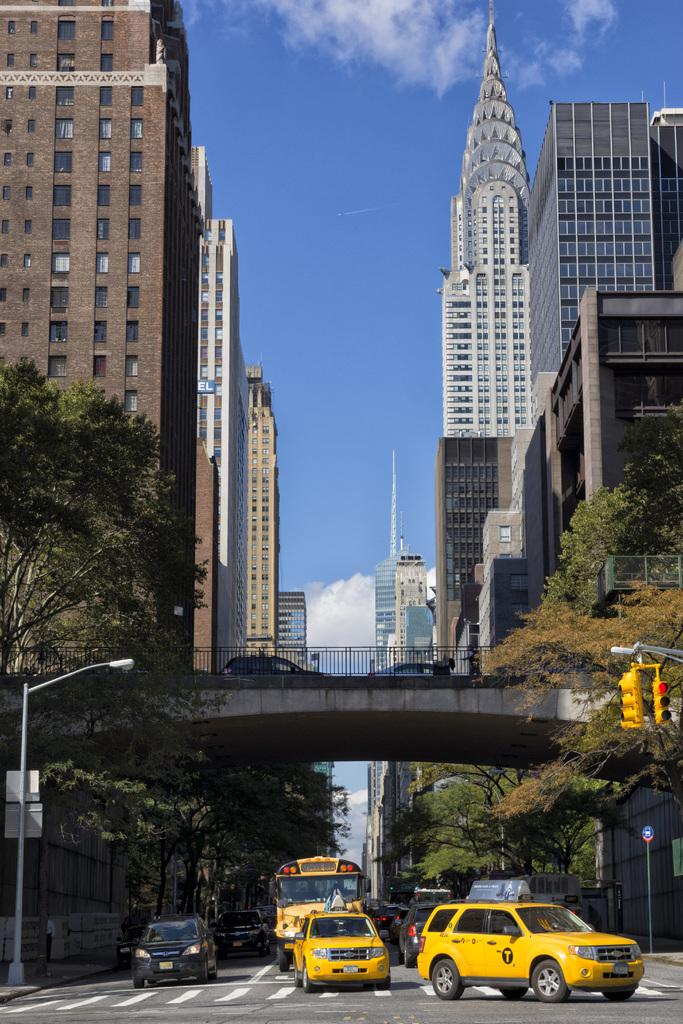What can be seen on the road in the image? There are vehicles on the road in the image. What structures are present in the image? There are poles, boards, a bridge, and buildings in the image. What is used to control traffic in the image? Traffic signal lights are present in the image. What type of vegetation is visible in the image? Trees are visible in the image. What is visible in the background of the image? The sky is visible in the background of the image. Can you tell me the name of the person getting a haircut in the image? There is no person getting a haircut in the image; it features vehicles, poles, boards, traffic signal lights, a bridge, buildings, trees, and the sky. Are there any cobwebs visible in the image? There are no cobwebs present in the image. 